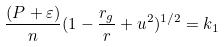<formula> <loc_0><loc_0><loc_500><loc_500>\frac { ( P + \varepsilon ) } { n } ( 1 - \frac { r _ { g } } { r } + u ^ { 2 } ) ^ { 1 / 2 } = k _ { 1 }</formula> 